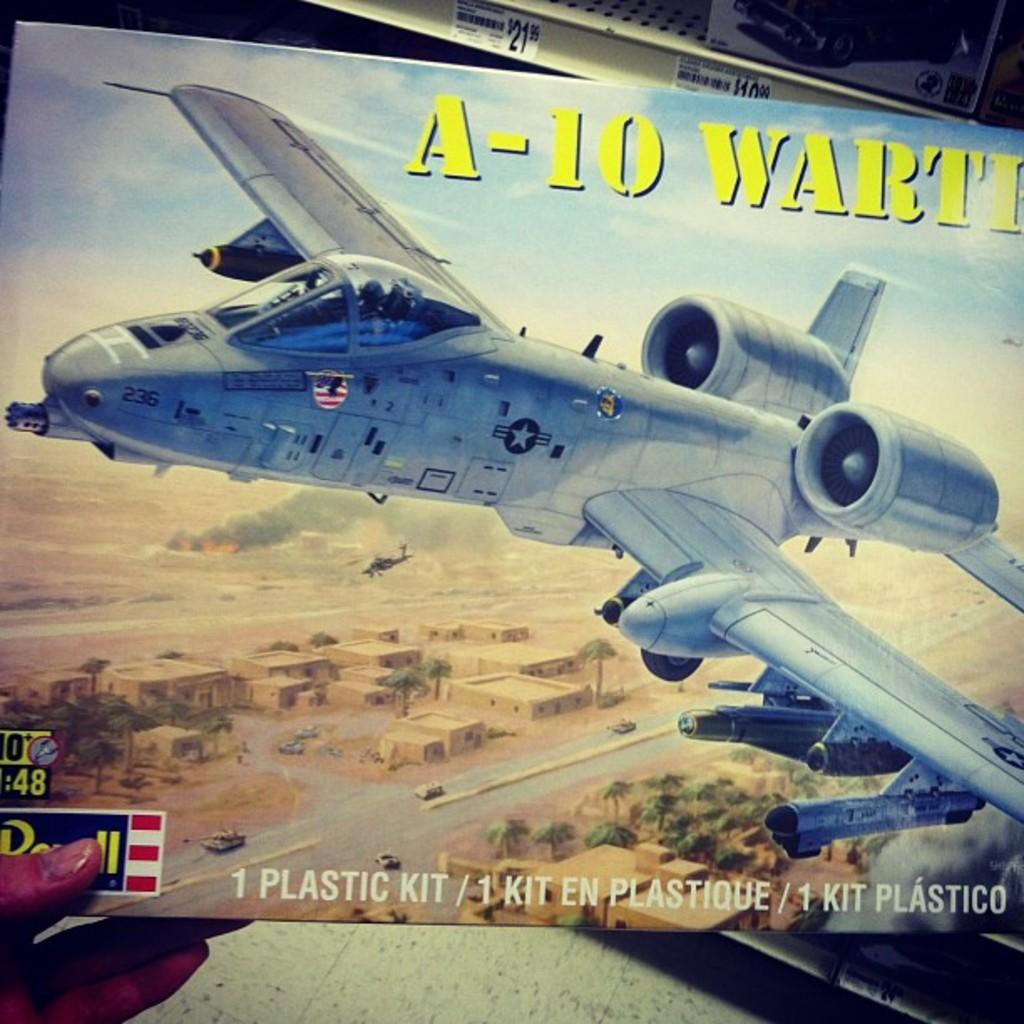<image>
Present a compact description of the photo's key features. a plane book that is called A-10 Warth 